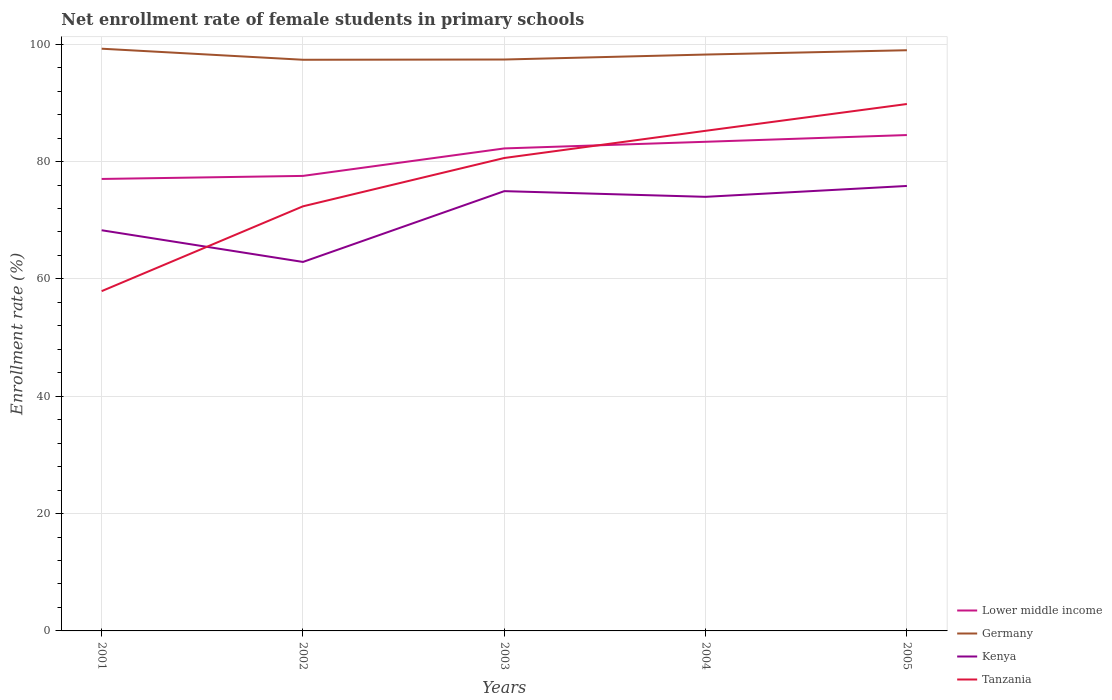How many different coloured lines are there?
Keep it short and to the point. 4. Is the number of lines equal to the number of legend labels?
Keep it short and to the point. Yes. Across all years, what is the maximum net enrollment rate of female students in primary schools in Germany?
Make the answer very short. 97.36. What is the total net enrollment rate of female students in primary schools in Lower middle income in the graph?
Provide a short and direct response. -0.52. What is the difference between the highest and the second highest net enrollment rate of female students in primary schools in Tanzania?
Give a very brief answer. 31.9. What is the difference between the highest and the lowest net enrollment rate of female students in primary schools in Tanzania?
Provide a succinct answer. 3. Is the net enrollment rate of female students in primary schools in Germany strictly greater than the net enrollment rate of female students in primary schools in Lower middle income over the years?
Keep it short and to the point. No. How many years are there in the graph?
Provide a short and direct response. 5. What is the difference between two consecutive major ticks on the Y-axis?
Ensure brevity in your answer.  20. Does the graph contain any zero values?
Ensure brevity in your answer.  No. Where does the legend appear in the graph?
Keep it short and to the point. Bottom right. How many legend labels are there?
Provide a short and direct response. 4. How are the legend labels stacked?
Give a very brief answer. Vertical. What is the title of the graph?
Keep it short and to the point. Net enrollment rate of female students in primary schools. What is the label or title of the X-axis?
Offer a very short reply. Years. What is the label or title of the Y-axis?
Provide a short and direct response. Enrollment rate (%). What is the Enrollment rate (%) in Lower middle income in 2001?
Provide a short and direct response. 77.04. What is the Enrollment rate (%) in Germany in 2001?
Make the answer very short. 99.24. What is the Enrollment rate (%) of Kenya in 2001?
Offer a very short reply. 68.29. What is the Enrollment rate (%) in Tanzania in 2001?
Your response must be concise. 57.92. What is the Enrollment rate (%) in Lower middle income in 2002?
Your response must be concise. 77.56. What is the Enrollment rate (%) of Germany in 2002?
Offer a very short reply. 97.36. What is the Enrollment rate (%) in Kenya in 2002?
Offer a very short reply. 62.89. What is the Enrollment rate (%) of Tanzania in 2002?
Provide a succinct answer. 72.37. What is the Enrollment rate (%) in Lower middle income in 2003?
Offer a very short reply. 82.24. What is the Enrollment rate (%) in Germany in 2003?
Your answer should be very brief. 97.4. What is the Enrollment rate (%) in Kenya in 2003?
Make the answer very short. 74.96. What is the Enrollment rate (%) of Tanzania in 2003?
Keep it short and to the point. 80.61. What is the Enrollment rate (%) in Lower middle income in 2004?
Your answer should be compact. 83.37. What is the Enrollment rate (%) in Germany in 2004?
Give a very brief answer. 98.24. What is the Enrollment rate (%) in Kenya in 2004?
Provide a succinct answer. 73.99. What is the Enrollment rate (%) of Tanzania in 2004?
Your answer should be very brief. 85.25. What is the Enrollment rate (%) of Lower middle income in 2005?
Provide a short and direct response. 84.52. What is the Enrollment rate (%) of Germany in 2005?
Give a very brief answer. 98.98. What is the Enrollment rate (%) in Kenya in 2005?
Offer a terse response. 75.85. What is the Enrollment rate (%) of Tanzania in 2005?
Provide a succinct answer. 89.81. Across all years, what is the maximum Enrollment rate (%) in Lower middle income?
Give a very brief answer. 84.52. Across all years, what is the maximum Enrollment rate (%) of Germany?
Offer a very short reply. 99.24. Across all years, what is the maximum Enrollment rate (%) in Kenya?
Your answer should be compact. 75.85. Across all years, what is the maximum Enrollment rate (%) in Tanzania?
Offer a very short reply. 89.81. Across all years, what is the minimum Enrollment rate (%) in Lower middle income?
Provide a succinct answer. 77.04. Across all years, what is the minimum Enrollment rate (%) in Germany?
Offer a very short reply. 97.36. Across all years, what is the minimum Enrollment rate (%) of Kenya?
Ensure brevity in your answer.  62.89. Across all years, what is the minimum Enrollment rate (%) of Tanzania?
Provide a short and direct response. 57.92. What is the total Enrollment rate (%) in Lower middle income in the graph?
Keep it short and to the point. 404.74. What is the total Enrollment rate (%) of Germany in the graph?
Offer a terse response. 491.21. What is the total Enrollment rate (%) of Kenya in the graph?
Offer a very short reply. 355.99. What is the total Enrollment rate (%) in Tanzania in the graph?
Provide a succinct answer. 385.96. What is the difference between the Enrollment rate (%) in Lower middle income in 2001 and that in 2002?
Provide a succinct answer. -0.52. What is the difference between the Enrollment rate (%) of Germany in 2001 and that in 2002?
Offer a very short reply. 1.89. What is the difference between the Enrollment rate (%) in Kenya in 2001 and that in 2002?
Your answer should be compact. 5.4. What is the difference between the Enrollment rate (%) of Tanzania in 2001 and that in 2002?
Keep it short and to the point. -14.46. What is the difference between the Enrollment rate (%) of Lower middle income in 2001 and that in 2003?
Your answer should be very brief. -5.2. What is the difference between the Enrollment rate (%) of Germany in 2001 and that in 2003?
Provide a succinct answer. 1.84. What is the difference between the Enrollment rate (%) of Kenya in 2001 and that in 2003?
Your answer should be very brief. -6.67. What is the difference between the Enrollment rate (%) in Tanzania in 2001 and that in 2003?
Give a very brief answer. -22.7. What is the difference between the Enrollment rate (%) in Lower middle income in 2001 and that in 2004?
Ensure brevity in your answer.  -6.33. What is the difference between the Enrollment rate (%) of Germany in 2001 and that in 2004?
Offer a very short reply. 1. What is the difference between the Enrollment rate (%) of Kenya in 2001 and that in 2004?
Ensure brevity in your answer.  -5.7. What is the difference between the Enrollment rate (%) of Tanzania in 2001 and that in 2004?
Offer a very short reply. -27.33. What is the difference between the Enrollment rate (%) in Lower middle income in 2001 and that in 2005?
Provide a succinct answer. -7.48. What is the difference between the Enrollment rate (%) of Germany in 2001 and that in 2005?
Provide a short and direct response. 0.26. What is the difference between the Enrollment rate (%) in Kenya in 2001 and that in 2005?
Make the answer very short. -7.55. What is the difference between the Enrollment rate (%) in Tanzania in 2001 and that in 2005?
Keep it short and to the point. -31.9. What is the difference between the Enrollment rate (%) in Lower middle income in 2002 and that in 2003?
Keep it short and to the point. -4.68. What is the difference between the Enrollment rate (%) in Germany in 2002 and that in 2003?
Provide a succinct answer. -0.04. What is the difference between the Enrollment rate (%) of Kenya in 2002 and that in 2003?
Ensure brevity in your answer.  -12.07. What is the difference between the Enrollment rate (%) of Tanzania in 2002 and that in 2003?
Offer a terse response. -8.24. What is the difference between the Enrollment rate (%) in Lower middle income in 2002 and that in 2004?
Make the answer very short. -5.81. What is the difference between the Enrollment rate (%) of Germany in 2002 and that in 2004?
Provide a succinct answer. -0.89. What is the difference between the Enrollment rate (%) of Kenya in 2002 and that in 2004?
Ensure brevity in your answer.  -11.1. What is the difference between the Enrollment rate (%) in Tanzania in 2002 and that in 2004?
Provide a succinct answer. -12.87. What is the difference between the Enrollment rate (%) in Lower middle income in 2002 and that in 2005?
Make the answer very short. -6.96. What is the difference between the Enrollment rate (%) of Germany in 2002 and that in 2005?
Offer a very short reply. -1.62. What is the difference between the Enrollment rate (%) of Kenya in 2002 and that in 2005?
Your response must be concise. -12.95. What is the difference between the Enrollment rate (%) of Tanzania in 2002 and that in 2005?
Provide a succinct answer. -17.44. What is the difference between the Enrollment rate (%) in Lower middle income in 2003 and that in 2004?
Give a very brief answer. -1.13. What is the difference between the Enrollment rate (%) of Germany in 2003 and that in 2004?
Your answer should be compact. -0.85. What is the difference between the Enrollment rate (%) in Kenya in 2003 and that in 2004?
Ensure brevity in your answer.  0.97. What is the difference between the Enrollment rate (%) of Tanzania in 2003 and that in 2004?
Offer a very short reply. -4.63. What is the difference between the Enrollment rate (%) of Lower middle income in 2003 and that in 2005?
Make the answer very short. -2.28. What is the difference between the Enrollment rate (%) in Germany in 2003 and that in 2005?
Offer a terse response. -1.58. What is the difference between the Enrollment rate (%) of Kenya in 2003 and that in 2005?
Offer a terse response. -0.89. What is the difference between the Enrollment rate (%) in Tanzania in 2003 and that in 2005?
Your answer should be compact. -9.2. What is the difference between the Enrollment rate (%) of Lower middle income in 2004 and that in 2005?
Your response must be concise. -1.15. What is the difference between the Enrollment rate (%) of Germany in 2004 and that in 2005?
Your answer should be very brief. -0.74. What is the difference between the Enrollment rate (%) of Kenya in 2004 and that in 2005?
Offer a very short reply. -1.85. What is the difference between the Enrollment rate (%) of Tanzania in 2004 and that in 2005?
Provide a short and direct response. -4.57. What is the difference between the Enrollment rate (%) in Lower middle income in 2001 and the Enrollment rate (%) in Germany in 2002?
Ensure brevity in your answer.  -20.32. What is the difference between the Enrollment rate (%) in Lower middle income in 2001 and the Enrollment rate (%) in Kenya in 2002?
Give a very brief answer. 14.15. What is the difference between the Enrollment rate (%) in Lower middle income in 2001 and the Enrollment rate (%) in Tanzania in 2002?
Keep it short and to the point. 4.67. What is the difference between the Enrollment rate (%) in Germany in 2001 and the Enrollment rate (%) in Kenya in 2002?
Your answer should be very brief. 36.35. What is the difference between the Enrollment rate (%) in Germany in 2001 and the Enrollment rate (%) in Tanzania in 2002?
Ensure brevity in your answer.  26.87. What is the difference between the Enrollment rate (%) of Kenya in 2001 and the Enrollment rate (%) of Tanzania in 2002?
Provide a short and direct response. -4.08. What is the difference between the Enrollment rate (%) in Lower middle income in 2001 and the Enrollment rate (%) in Germany in 2003?
Offer a terse response. -20.36. What is the difference between the Enrollment rate (%) of Lower middle income in 2001 and the Enrollment rate (%) of Kenya in 2003?
Offer a very short reply. 2.08. What is the difference between the Enrollment rate (%) of Lower middle income in 2001 and the Enrollment rate (%) of Tanzania in 2003?
Offer a very short reply. -3.57. What is the difference between the Enrollment rate (%) in Germany in 2001 and the Enrollment rate (%) in Kenya in 2003?
Make the answer very short. 24.28. What is the difference between the Enrollment rate (%) of Germany in 2001 and the Enrollment rate (%) of Tanzania in 2003?
Keep it short and to the point. 18.63. What is the difference between the Enrollment rate (%) in Kenya in 2001 and the Enrollment rate (%) in Tanzania in 2003?
Your answer should be compact. -12.32. What is the difference between the Enrollment rate (%) of Lower middle income in 2001 and the Enrollment rate (%) of Germany in 2004?
Provide a short and direct response. -21.2. What is the difference between the Enrollment rate (%) of Lower middle income in 2001 and the Enrollment rate (%) of Kenya in 2004?
Provide a succinct answer. 3.05. What is the difference between the Enrollment rate (%) in Lower middle income in 2001 and the Enrollment rate (%) in Tanzania in 2004?
Provide a succinct answer. -8.21. What is the difference between the Enrollment rate (%) in Germany in 2001 and the Enrollment rate (%) in Kenya in 2004?
Provide a short and direct response. 25.25. What is the difference between the Enrollment rate (%) of Germany in 2001 and the Enrollment rate (%) of Tanzania in 2004?
Keep it short and to the point. 14. What is the difference between the Enrollment rate (%) of Kenya in 2001 and the Enrollment rate (%) of Tanzania in 2004?
Provide a succinct answer. -16.95. What is the difference between the Enrollment rate (%) of Lower middle income in 2001 and the Enrollment rate (%) of Germany in 2005?
Your answer should be very brief. -21.94. What is the difference between the Enrollment rate (%) in Lower middle income in 2001 and the Enrollment rate (%) in Kenya in 2005?
Make the answer very short. 1.19. What is the difference between the Enrollment rate (%) of Lower middle income in 2001 and the Enrollment rate (%) of Tanzania in 2005?
Provide a short and direct response. -12.77. What is the difference between the Enrollment rate (%) of Germany in 2001 and the Enrollment rate (%) of Kenya in 2005?
Ensure brevity in your answer.  23.39. What is the difference between the Enrollment rate (%) in Germany in 2001 and the Enrollment rate (%) in Tanzania in 2005?
Ensure brevity in your answer.  9.43. What is the difference between the Enrollment rate (%) of Kenya in 2001 and the Enrollment rate (%) of Tanzania in 2005?
Give a very brief answer. -21.52. What is the difference between the Enrollment rate (%) of Lower middle income in 2002 and the Enrollment rate (%) of Germany in 2003?
Offer a terse response. -19.84. What is the difference between the Enrollment rate (%) in Lower middle income in 2002 and the Enrollment rate (%) in Kenya in 2003?
Offer a very short reply. 2.6. What is the difference between the Enrollment rate (%) of Lower middle income in 2002 and the Enrollment rate (%) of Tanzania in 2003?
Give a very brief answer. -3.05. What is the difference between the Enrollment rate (%) of Germany in 2002 and the Enrollment rate (%) of Kenya in 2003?
Provide a succinct answer. 22.39. What is the difference between the Enrollment rate (%) of Germany in 2002 and the Enrollment rate (%) of Tanzania in 2003?
Your answer should be very brief. 16.74. What is the difference between the Enrollment rate (%) of Kenya in 2002 and the Enrollment rate (%) of Tanzania in 2003?
Offer a terse response. -17.72. What is the difference between the Enrollment rate (%) of Lower middle income in 2002 and the Enrollment rate (%) of Germany in 2004?
Your response must be concise. -20.68. What is the difference between the Enrollment rate (%) in Lower middle income in 2002 and the Enrollment rate (%) in Kenya in 2004?
Make the answer very short. 3.57. What is the difference between the Enrollment rate (%) in Lower middle income in 2002 and the Enrollment rate (%) in Tanzania in 2004?
Your answer should be very brief. -7.69. What is the difference between the Enrollment rate (%) of Germany in 2002 and the Enrollment rate (%) of Kenya in 2004?
Provide a succinct answer. 23.36. What is the difference between the Enrollment rate (%) of Germany in 2002 and the Enrollment rate (%) of Tanzania in 2004?
Keep it short and to the point. 12.11. What is the difference between the Enrollment rate (%) in Kenya in 2002 and the Enrollment rate (%) in Tanzania in 2004?
Your answer should be very brief. -22.35. What is the difference between the Enrollment rate (%) in Lower middle income in 2002 and the Enrollment rate (%) in Germany in 2005?
Offer a terse response. -21.42. What is the difference between the Enrollment rate (%) in Lower middle income in 2002 and the Enrollment rate (%) in Kenya in 2005?
Keep it short and to the point. 1.71. What is the difference between the Enrollment rate (%) in Lower middle income in 2002 and the Enrollment rate (%) in Tanzania in 2005?
Make the answer very short. -12.25. What is the difference between the Enrollment rate (%) in Germany in 2002 and the Enrollment rate (%) in Kenya in 2005?
Make the answer very short. 21.51. What is the difference between the Enrollment rate (%) in Germany in 2002 and the Enrollment rate (%) in Tanzania in 2005?
Ensure brevity in your answer.  7.54. What is the difference between the Enrollment rate (%) in Kenya in 2002 and the Enrollment rate (%) in Tanzania in 2005?
Give a very brief answer. -26.92. What is the difference between the Enrollment rate (%) of Lower middle income in 2003 and the Enrollment rate (%) of Germany in 2004?
Make the answer very short. -16. What is the difference between the Enrollment rate (%) of Lower middle income in 2003 and the Enrollment rate (%) of Kenya in 2004?
Your answer should be very brief. 8.25. What is the difference between the Enrollment rate (%) in Lower middle income in 2003 and the Enrollment rate (%) in Tanzania in 2004?
Your answer should be very brief. -3. What is the difference between the Enrollment rate (%) in Germany in 2003 and the Enrollment rate (%) in Kenya in 2004?
Make the answer very short. 23.4. What is the difference between the Enrollment rate (%) in Germany in 2003 and the Enrollment rate (%) in Tanzania in 2004?
Offer a very short reply. 12.15. What is the difference between the Enrollment rate (%) of Kenya in 2003 and the Enrollment rate (%) of Tanzania in 2004?
Your answer should be compact. -10.28. What is the difference between the Enrollment rate (%) in Lower middle income in 2003 and the Enrollment rate (%) in Germany in 2005?
Provide a short and direct response. -16.74. What is the difference between the Enrollment rate (%) in Lower middle income in 2003 and the Enrollment rate (%) in Kenya in 2005?
Your answer should be compact. 6.4. What is the difference between the Enrollment rate (%) of Lower middle income in 2003 and the Enrollment rate (%) of Tanzania in 2005?
Offer a very short reply. -7.57. What is the difference between the Enrollment rate (%) of Germany in 2003 and the Enrollment rate (%) of Kenya in 2005?
Keep it short and to the point. 21.55. What is the difference between the Enrollment rate (%) in Germany in 2003 and the Enrollment rate (%) in Tanzania in 2005?
Offer a very short reply. 7.58. What is the difference between the Enrollment rate (%) in Kenya in 2003 and the Enrollment rate (%) in Tanzania in 2005?
Give a very brief answer. -14.85. What is the difference between the Enrollment rate (%) of Lower middle income in 2004 and the Enrollment rate (%) of Germany in 2005?
Provide a succinct answer. -15.61. What is the difference between the Enrollment rate (%) of Lower middle income in 2004 and the Enrollment rate (%) of Kenya in 2005?
Provide a succinct answer. 7.53. What is the difference between the Enrollment rate (%) in Lower middle income in 2004 and the Enrollment rate (%) in Tanzania in 2005?
Offer a very short reply. -6.44. What is the difference between the Enrollment rate (%) in Germany in 2004 and the Enrollment rate (%) in Kenya in 2005?
Your answer should be very brief. 22.4. What is the difference between the Enrollment rate (%) of Germany in 2004 and the Enrollment rate (%) of Tanzania in 2005?
Your answer should be very brief. 8.43. What is the difference between the Enrollment rate (%) of Kenya in 2004 and the Enrollment rate (%) of Tanzania in 2005?
Offer a very short reply. -15.82. What is the average Enrollment rate (%) in Lower middle income per year?
Offer a very short reply. 80.95. What is the average Enrollment rate (%) in Germany per year?
Provide a short and direct response. 98.24. What is the average Enrollment rate (%) in Kenya per year?
Offer a very short reply. 71.2. What is the average Enrollment rate (%) in Tanzania per year?
Provide a short and direct response. 77.19. In the year 2001, what is the difference between the Enrollment rate (%) in Lower middle income and Enrollment rate (%) in Germany?
Ensure brevity in your answer.  -22.2. In the year 2001, what is the difference between the Enrollment rate (%) of Lower middle income and Enrollment rate (%) of Kenya?
Make the answer very short. 8.75. In the year 2001, what is the difference between the Enrollment rate (%) of Lower middle income and Enrollment rate (%) of Tanzania?
Provide a succinct answer. 19.12. In the year 2001, what is the difference between the Enrollment rate (%) in Germany and Enrollment rate (%) in Kenya?
Provide a succinct answer. 30.95. In the year 2001, what is the difference between the Enrollment rate (%) of Germany and Enrollment rate (%) of Tanzania?
Make the answer very short. 41.33. In the year 2001, what is the difference between the Enrollment rate (%) of Kenya and Enrollment rate (%) of Tanzania?
Offer a very short reply. 10.38. In the year 2002, what is the difference between the Enrollment rate (%) of Lower middle income and Enrollment rate (%) of Germany?
Your response must be concise. -19.8. In the year 2002, what is the difference between the Enrollment rate (%) in Lower middle income and Enrollment rate (%) in Kenya?
Your answer should be very brief. 14.67. In the year 2002, what is the difference between the Enrollment rate (%) in Lower middle income and Enrollment rate (%) in Tanzania?
Your answer should be very brief. 5.18. In the year 2002, what is the difference between the Enrollment rate (%) of Germany and Enrollment rate (%) of Kenya?
Provide a short and direct response. 34.46. In the year 2002, what is the difference between the Enrollment rate (%) in Germany and Enrollment rate (%) in Tanzania?
Offer a very short reply. 24.98. In the year 2002, what is the difference between the Enrollment rate (%) in Kenya and Enrollment rate (%) in Tanzania?
Your answer should be very brief. -9.48. In the year 2003, what is the difference between the Enrollment rate (%) of Lower middle income and Enrollment rate (%) of Germany?
Provide a succinct answer. -15.15. In the year 2003, what is the difference between the Enrollment rate (%) of Lower middle income and Enrollment rate (%) of Kenya?
Your answer should be very brief. 7.28. In the year 2003, what is the difference between the Enrollment rate (%) of Lower middle income and Enrollment rate (%) of Tanzania?
Offer a very short reply. 1.63. In the year 2003, what is the difference between the Enrollment rate (%) in Germany and Enrollment rate (%) in Kenya?
Your answer should be compact. 22.44. In the year 2003, what is the difference between the Enrollment rate (%) of Germany and Enrollment rate (%) of Tanzania?
Make the answer very short. 16.78. In the year 2003, what is the difference between the Enrollment rate (%) of Kenya and Enrollment rate (%) of Tanzania?
Ensure brevity in your answer.  -5.65. In the year 2004, what is the difference between the Enrollment rate (%) of Lower middle income and Enrollment rate (%) of Germany?
Ensure brevity in your answer.  -14.87. In the year 2004, what is the difference between the Enrollment rate (%) of Lower middle income and Enrollment rate (%) of Kenya?
Offer a very short reply. 9.38. In the year 2004, what is the difference between the Enrollment rate (%) in Lower middle income and Enrollment rate (%) in Tanzania?
Your response must be concise. -1.87. In the year 2004, what is the difference between the Enrollment rate (%) in Germany and Enrollment rate (%) in Kenya?
Keep it short and to the point. 24.25. In the year 2004, what is the difference between the Enrollment rate (%) in Germany and Enrollment rate (%) in Tanzania?
Make the answer very short. 13. In the year 2004, what is the difference between the Enrollment rate (%) in Kenya and Enrollment rate (%) in Tanzania?
Your answer should be compact. -11.25. In the year 2005, what is the difference between the Enrollment rate (%) of Lower middle income and Enrollment rate (%) of Germany?
Your answer should be very brief. -14.46. In the year 2005, what is the difference between the Enrollment rate (%) in Lower middle income and Enrollment rate (%) in Kenya?
Keep it short and to the point. 8.68. In the year 2005, what is the difference between the Enrollment rate (%) of Lower middle income and Enrollment rate (%) of Tanzania?
Make the answer very short. -5.29. In the year 2005, what is the difference between the Enrollment rate (%) of Germany and Enrollment rate (%) of Kenya?
Offer a terse response. 23.13. In the year 2005, what is the difference between the Enrollment rate (%) in Germany and Enrollment rate (%) in Tanzania?
Keep it short and to the point. 9.17. In the year 2005, what is the difference between the Enrollment rate (%) of Kenya and Enrollment rate (%) of Tanzania?
Your answer should be compact. -13.97. What is the ratio of the Enrollment rate (%) in Lower middle income in 2001 to that in 2002?
Offer a very short reply. 0.99. What is the ratio of the Enrollment rate (%) in Germany in 2001 to that in 2002?
Give a very brief answer. 1.02. What is the ratio of the Enrollment rate (%) of Kenya in 2001 to that in 2002?
Your answer should be compact. 1.09. What is the ratio of the Enrollment rate (%) in Tanzania in 2001 to that in 2002?
Your answer should be very brief. 0.8. What is the ratio of the Enrollment rate (%) in Lower middle income in 2001 to that in 2003?
Keep it short and to the point. 0.94. What is the ratio of the Enrollment rate (%) in Germany in 2001 to that in 2003?
Keep it short and to the point. 1.02. What is the ratio of the Enrollment rate (%) in Kenya in 2001 to that in 2003?
Keep it short and to the point. 0.91. What is the ratio of the Enrollment rate (%) in Tanzania in 2001 to that in 2003?
Provide a succinct answer. 0.72. What is the ratio of the Enrollment rate (%) of Lower middle income in 2001 to that in 2004?
Your answer should be compact. 0.92. What is the ratio of the Enrollment rate (%) of Germany in 2001 to that in 2004?
Your answer should be compact. 1.01. What is the ratio of the Enrollment rate (%) of Kenya in 2001 to that in 2004?
Ensure brevity in your answer.  0.92. What is the ratio of the Enrollment rate (%) of Tanzania in 2001 to that in 2004?
Make the answer very short. 0.68. What is the ratio of the Enrollment rate (%) in Lower middle income in 2001 to that in 2005?
Keep it short and to the point. 0.91. What is the ratio of the Enrollment rate (%) of Germany in 2001 to that in 2005?
Provide a short and direct response. 1. What is the ratio of the Enrollment rate (%) in Kenya in 2001 to that in 2005?
Make the answer very short. 0.9. What is the ratio of the Enrollment rate (%) in Tanzania in 2001 to that in 2005?
Offer a very short reply. 0.64. What is the ratio of the Enrollment rate (%) in Lower middle income in 2002 to that in 2003?
Your response must be concise. 0.94. What is the ratio of the Enrollment rate (%) of Kenya in 2002 to that in 2003?
Keep it short and to the point. 0.84. What is the ratio of the Enrollment rate (%) in Tanzania in 2002 to that in 2003?
Keep it short and to the point. 0.9. What is the ratio of the Enrollment rate (%) in Lower middle income in 2002 to that in 2004?
Keep it short and to the point. 0.93. What is the ratio of the Enrollment rate (%) of Kenya in 2002 to that in 2004?
Make the answer very short. 0.85. What is the ratio of the Enrollment rate (%) in Tanzania in 2002 to that in 2004?
Your answer should be very brief. 0.85. What is the ratio of the Enrollment rate (%) of Lower middle income in 2002 to that in 2005?
Ensure brevity in your answer.  0.92. What is the ratio of the Enrollment rate (%) in Germany in 2002 to that in 2005?
Your answer should be compact. 0.98. What is the ratio of the Enrollment rate (%) in Kenya in 2002 to that in 2005?
Ensure brevity in your answer.  0.83. What is the ratio of the Enrollment rate (%) in Tanzania in 2002 to that in 2005?
Your answer should be very brief. 0.81. What is the ratio of the Enrollment rate (%) of Lower middle income in 2003 to that in 2004?
Provide a succinct answer. 0.99. What is the ratio of the Enrollment rate (%) of Germany in 2003 to that in 2004?
Provide a short and direct response. 0.99. What is the ratio of the Enrollment rate (%) of Kenya in 2003 to that in 2004?
Give a very brief answer. 1.01. What is the ratio of the Enrollment rate (%) in Tanzania in 2003 to that in 2004?
Ensure brevity in your answer.  0.95. What is the ratio of the Enrollment rate (%) of Lower middle income in 2003 to that in 2005?
Your answer should be compact. 0.97. What is the ratio of the Enrollment rate (%) in Kenya in 2003 to that in 2005?
Offer a very short reply. 0.99. What is the ratio of the Enrollment rate (%) in Tanzania in 2003 to that in 2005?
Keep it short and to the point. 0.9. What is the ratio of the Enrollment rate (%) in Lower middle income in 2004 to that in 2005?
Ensure brevity in your answer.  0.99. What is the ratio of the Enrollment rate (%) in Kenya in 2004 to that in 2005?
Provide a succinct answer. 0.98. What is the ratio of the Enrollment rate (%) of Tanzania in 2004 to that in 2005?
Give a very brief answer. 0.95. What is the difference between the highest and the second highest Enrollment rate (%) of Lower middle income?
Offer a very short reply. 1.15. What is the difference between the highest and the second highest Enrollment rate (%) in Germany?
Provide a succinct answer. 0.26. What is the difference between the highest and the second highest Enrollment rate (%) in Kenya?
Give a very brief answer. 0.89. What is the difference between the highest and the second highest Enrollment rate (%) in Tanzania?
Ensure brevity in your answer.  4.57. What is the difference between the highest and the lowest Enrollment rate (%) of Lower middle income?
Keep it short and to the point. 7.48. What is the difference between the highest and the lowest Enrollment rate (%) in Germany?
Offer a very short reply. 1.89. What is the difference between the highest and the lowest Enrollment rate (%) of Kenya?
Your response must be concise. 12.95. What is the difference between the highest and the lowest Enrollment rate (%) in Tanzania?
Your answer should be very brief. 31.9. 